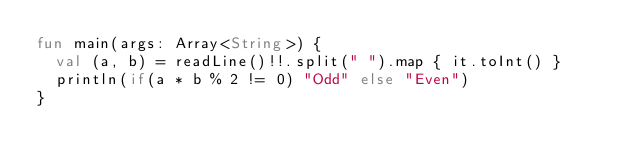<code> <loc_0><loc_0><loc_500><loc_500><_Kotlin_>fun main(args: Array<String>) {
  val (a, b) = readLine()!!.split(" ").map { it.toInt() }
  println(if(a * b % 2 != 0) "Odd" else "Even")
}</code> 